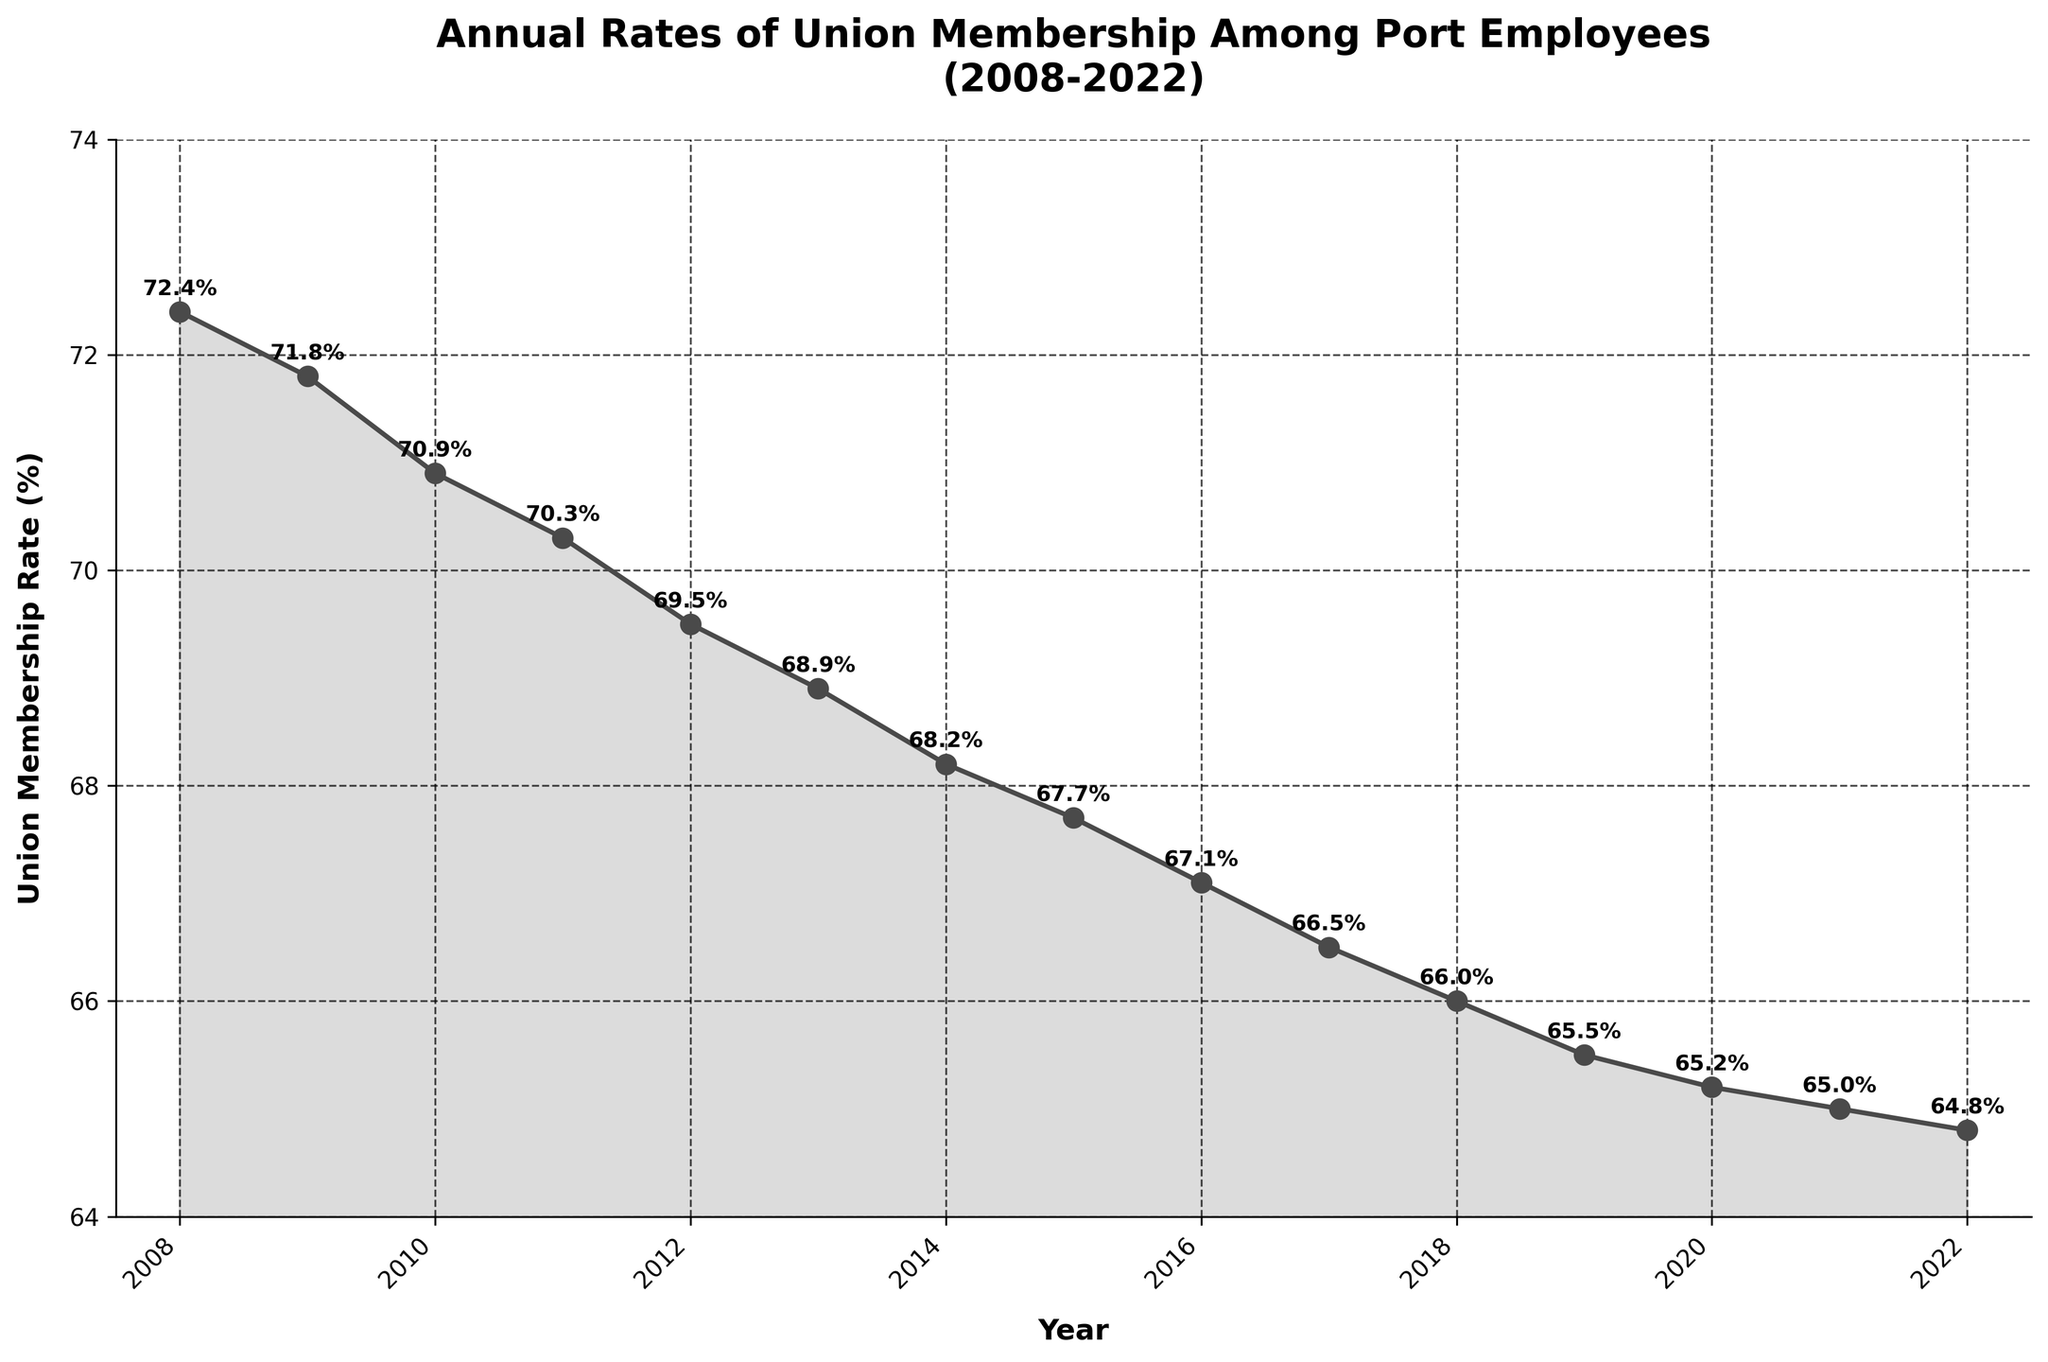How does the union membership rate change from 2008 to 2012? The union membership rate starts at 72.4% in 2008 and decreases to 69.5% in 2012. The difference between them is 72.4% - 69.5% = 2.9%.
Answer: It decreases by 2.9% What was the union membership rate in 2015? To answer this, look directly at the data point for the year 2015. The union membership rate in 2015 is 67.7%.
Answer: 67.7% In what year does the union membership rate drop below 70% for the first time? Identify the first year in the plot where the rate dips below 70%. This happens in the year 2012 when the rate is 69.5%.
Answer: 2012 What is the range of the union membership rates between 2008 and 2022? The range is the difference between the highest rate (72.4% in 2008) and the lowest rate (64.8% in 2022). The range is 72.4% - 64.8% = 7.6%.
Answer: 7.6% By how much did the union membership rate change between 2010 and 2011? The rate in 2010 is 70.9% and in 2011 is 70.3%. Subtracting the latter from the former gives 70.9% - 70.3% = 0.6%.
Answer: 0.6% Which year shows the smallest rate decrease from the previous year? Compare the year-to-year decreases: 2008-2009 (0.6%), 2009-2010 (0.9%), 2010-2011 (0.6%), 2011-2012 (0.8%), etc. The smallest decrease is 2008-2009 (0.6%) or 2010-2011 (0.6%).
Answer: 2008-2009 or 2010-2011 What is the average union membership rate over the 15 years? Sum all the rates from 2008 to 2022 and divide by 15. (72.4 + 71.8 + 70.9 + ... + 64.8) / 15 = 68.03%.
Answer: 68.03% How many times does the membership rate fall by more than 0.5% from one year to the next? By inspecting each year-to-year change: 2008-2009 (0.6%), 2009-2010 (0.9%), 2010-2011 (0.6%), 2011-2012 (0.8%), 2012-2013 (0.6%), 2013-2014 (0.7%), 2014-2015 (0.5%), 2015-2016 (0.6%), 2016-2017 (0.6%), 2017-2018 (0.5%), 2018-2019 (0.5%), 2019-2020 (0.3%), 2020-2021 (0.2%), 2021-2022 (0.2%). The count is 9 times.
Answer: 9 What is the median union membership rate from 2008 to 2022? Sorting the rates and finding the middle value, we get the median between the 7th and 8th values in sorted order. Median = (68.2% + 68.9%) / 2 = 68.55%.
Answer: 68.55% Is the trend of union membership rates increasing or decreasing over the 15-year period? Observing the overall direction, the rates consistently decline from 72.4% in 2008 to 64.8% in 2022. This indicates a decreasing trend.
Answer: Decreasing 